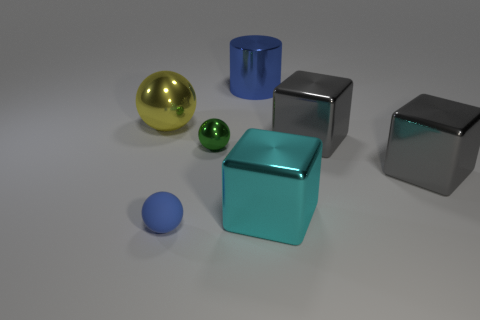Subtract all small green spheres. How many spheres are left? 2 Add 2 small blue objects. How many small blue objects are left? 3 Add 7 big red matte balls. How many big red matte balls exist? 7 Add 1 green balls. How many objects exist? 8 Subtract all gray blocks. How many blocks are left? 1 Subtract 1 cyan cubes. How many objects are left? 6 Subtract all cubes. How many objects are left? 4 Subtract 3 cubes. How many cubes are left? 0 Subtract all yellow spheres. Subtract all cyan cylinders. How many spheres are left? 2 Subtract all gray cylinders. How many gray blocks are left? 2 